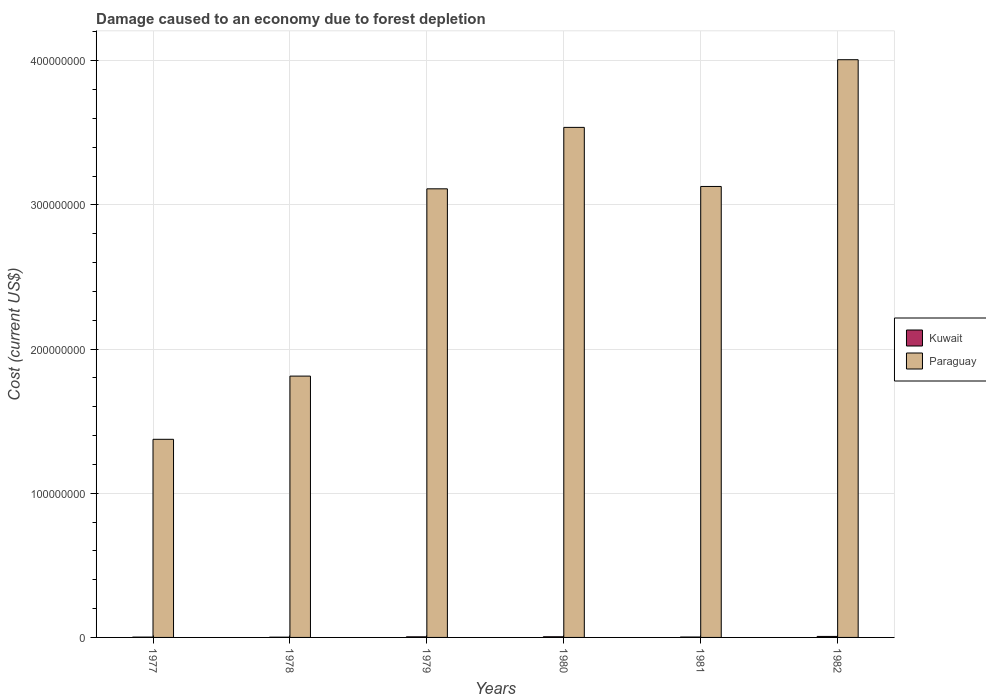Are the number of bars per tick equal to the number of legend labels?
Provide a short and direct response. Yes. How many bars are there on the 5th tick from the left?
Offer a terse response. 2. How many bars are there on the 4th tick from the right?
Make the answer very short. 2. In how many cases, is the number of bars for a given year not equal to the number of legend labels?
Your answer should be compact. 0. What is the cost of damage caused due to forest depletion in Paraguay in 1981?
Provide a succinct answer. 3.13e+08. Across all years, what is the maximum cost of damage caused due to forest depletion in Paraguay?
Your answer should be very brief. 4.01e+08. Across all years, what is the minimum cost of damage caused due to forest depletion in Paraguay?
Your response must be concise. 1.37e+08. In which year was the cost of damage caused due to forest depletion in Paraguay minimum?
Offer a very short reply. 1977. What is the total cost of damage caused due to forest depletion in Kuwait in the graph?
Offer a very short reply. 2.26e+06. What is the difference between the cost of damage caused due to forest depletion in Paraguay in 1979 and that in 1981?
Ensure brevity in your answer.  -1.63e+06. What is the difference between the cost of damage caused due to forest depletion in Paraguay in 1981 and the cost of damage caused due to forest depletion in Kuwait in 1977?
Ensure brevity in your answer.  3.13e+08. What is the average cost of damage caused due to forest depletion in Kuwait per year?
Keep it short and to the point. 3.76e+05. In the year 1977, what is the difference between the cost of damage caused due to forest depletion in Paraguay and cost of damage caused due to forest depletion in Kuwait?
Make the answer very short. 1.37e+08. In how many years, is the cost of damage caused due to forest depletion in Paraguay greater than 140000000 US$?
Offer a very short reply. 5. What is the ratio of the cost of damage caused due to forest depletion in Kuwait in 1979 to that in 1980?
Your answer should be compact. 0.9. Is the difference between the cost of damage caused due to forest depletion in Paraguay in 1977 and 1982 greater than the difference between the cost of damage caused due to forest depletion in Kuwait in 1977 and 1982?
Your answer should be very brief. No. What is the difference between the highest and the second highest cost of damage caused due to forest depletion in Kuwait?
Provide a succinct answer. 2.28e+05. What is the difference between the highest and the lowest cost of damage caused due to forest depletion in Paraguay?
Your answer should be very brief. 2.63e+08. What does the 2nd bar from the left in 1980 represents?
Your answer should be compact. Paraguay. What does the 2nd bar from the right in 1980 represents?
Provide a short and direct response. Kuwait. How many bars are there?
Make the answer very short. 12. What is the difference between two consecutive major ticks on the Y-axis?
Your answer should be compact. 1.00e+08. Are the values on the major ticks of Y-axis written in scientific E-notation?
Offer a terse response. No. Does the graph contain grids?
Your answer should be very brief. Yes. How are the legend labels stacked?
Offer a very short reply. Vertical. What is the title of the graph?
Give a very brief answer. Damage caused to an economy due to forest depletion. What is the label or title of the X-axis?
Your answer should be compact. Years. What is the label or title of the Y-axis?
Give a very brief answer. Cost (current US$). What is the Cost (current US$) of Kuwait in 1977?
Your answer should be compact. 2.24e+05. What is the Cost (current US$) of Paraguay in 1977?
Ensure brevity in your answer.  1.37e+08. What is the Cost (current US$) of Kuwait in 1978?
Provide a short and direct response. 1.75e+05. What is the Cost (current US$) of Paraguay in 1978?
Keep it short and to the point. 1.81e+08. What is the Cost (current US$) of Kuwait in 1979?
Your answer should be very brief. 4.19e+05. What is the Cost (current US$) of Paraguay in 1979?
Your response must be concise. 3.11e+08. What is the Cost (current US$) of Kuwait in 1980?
Your response must be concise. 4.67e+05. What is the Cost (current US$) of Paraguay in 1980?
Make the answer very short. 3.54e+08. What is the Cost (current US$) in Kuwait in 1981?
Offer a terse response. 2.76e+05. What is the Cost (current US$) of Paraguay in 1981?
Provide a succinct answer. 3.13e+08. What is the Cost (current US$) in Kuwait in 1982?
Provide a succinct answer. 6.96e+05. What is the Cost (current US$) of Paraguay in 1982?
Offer a terse response. 4.01e+08. Across all years, what is the maximum Cost (current US$) in Kuwait?
Provide a short and direct response. 6.96e+05. Across all years, what is the maximum Cost (current US$) in Paraguay?
Provide a succinct answer. 4.01e+08. Across all years, what is the minimum Cost (current US$) of Kuwait?
Offer a terse response. 1.75e+05. Across all years, what is the minimum Cost (current US$) in Paraguay?
Ensure brevity in your answer.  1.37e+08. What is the total Cost (current US$) in Kuwait in the graph?
Make the answer very short. 2.26e+06. What is the total Cost (current US$) of Paraguay in the graph?
Give a very brief answer. 1.70e+09. What is the difference between the Cost (current US$) of Kuwait in 1977 and that in 1978?
Ensure brevity in your answer.  4.87e+04. What is the difference between the Cost (current US$) of Paraguay in 1977 and that in 1978?
Your answer should be compact. -4.38e+07. What is the difference between the Cost (current US$) of Kuwait in 1977 and that in 1979?
Give a very brief answer. -1.95e+05. What is the difference between the Cost (current US$) of Paraguay in 1977 and that in 1979?
Offer a terse response. -1.74e+08. What is the difference between the Cost (current US$) of Kuwait in 1977 and that in 1980?
Your answer should be very brief. -2.43e+05. What is the difference between the Cost (current US$) in Paraguay in 1977 and that in 1980?
Offer a terse response. -2.16e+08. What is the difference between the Cost (current US$) of Kuwait in 1977 and that in 1981?
Make the answer very short. -5.13e+04. What is the difference between the Cost (current US$) in Paraguay in 1977 and that in 1981?
Your response must be concise. -1.75e+08. What is the difference between the Cost (current US$) of Kuwait in 1977 and that in 1982?
Your answer should be compact. -4.71e+05. What is the difference between the Cost (current US$) in Paraguay in 1977 and that in 1982?
Offer a very short reply. -2.63e+08. What is the difference between the Cost (current US$) in Kuwait in 1978 and that in 1979?
Provide a short and direct response. -2.44e+05. What is the difference between the Cost (current US$) of Paraguay in 1978 and that in 1979?
Keep it short and to the point. -1.30e+08. What is the difference between the Cost (current US$) in Kuwait in 1978 and that in 1980?
Your response must be concise. -2.92e+05. What is the difference between the Cost (current US$) of Paraguay in 1978 and that in 1980?
Ensure brevity in your answer.  -1.72e+08. What is the difference between the Cost (current US$) of Kuwait in 1978 and that in 1981?
Offer a very short reply. -1.00e+05. What is the difference between the Cost (current US$) in Paraguay in 1978 and that in 1981?
Your answer should be very brief. -1.32e+08. What is the difference between the Cost (current US$) of Kuwait in 1978 and that in 1982?
Offer a very short reply. -5.20e+05. What is the difference between the Cost (current US$) of Paraguay in 1978 and that in 1982?
Give a very brief answer. -2.19e+08. What is the difference between the Cost (current US$) in Kuwait in 1979 and that in 1980?
Provide a succinct answer. -4.83e+04. What is the difference between the Cost (current US$) in Paraguay in 1979 and that in 1980?
Offer a terse response. -4.26e+07. What is the difference between the Cost (current US$) of Kuwait in 1979 and that in 1981?
Give a very brief answer. 1.44e+05. What is the difference between the Cost (current US$) of Paraguay in 1979 and that in 1981?
Make the answer very short. -1.63e+06. What is the difference between the Cost (current US$) in Kuwait in 1979 and that in 1982?
Your answer should be compact. -2.76e+05. What is the difference between the Cost (current US$) in Paraguay in 1979 and that in 1982?
Your response must be concise. -8.95e+07. What is the difference between the Cost (current US$) in Kuwait in 1980 and that in 1981?
Offer a very short reply. 1.92e+05. What is the difference between the Cost (current US$) of Paraguay in 1980 and that in 1981?
Your response must be concise. 4.10e+07. What is the difference between the Cost (current US$) in Kuwait in 1980 and that in 1982?
Your response must be concise. -2.28e+05. What is the difference between the Cost (current US$) of Paraguay in 1980 and that in 1982?
Offer a very short reply. -4.69e+07. What is the difference between the Cost (current US$) in Kuwait in 1981 and that in 1982?
Your response must be concise. -4.20e+05. What is the difference between the Cost (current US$) of Paraguay in 1981 and that in 1982?
Keep it short and to the point. -8.79e+07. What is the difference between the Cost (current US$) of Kuwait in 1977 and the Cost (current US$) of Paraguay in 1978?
Your answer should be very brief. -1.81e+08. What is the difference between the Cost (current US$) in Kuwait in 1977 and the Cost (current US$) in Paraguay in 1979?
Keep it short and to the point. -3.11e+08. What is the difference between the Cost (current US$) of Kuwait in 1977 and the Cost (current US$) of Paraguay in 1980?
Your answer should be very brief. -3.54e+08. What is the difference between the Cost (current US$) in Kuwait in 1977 and the Cost (current US$) in Paraguay in 1981?
Keep it short and to the point. -3.13e+08. What is the difference between the Cost (current US$) in Kuwait in 1977 and the Cost (current US$) in Paraguay in 1982?
Ensure brevity in your answer.  -4.00e+08. What is the difference between the Cost (current US$) in Kuwait in 1978 and the Cost (current US$) in Paraguay in 1979?
Provide a succinct answer. -3.11e+08. What is the difference between the Cost (current US$) of Kuwait in 1978 and the Cost (current US$) of Paraguay in 1980?
Provide a succinct answer. -3.54e+08. What is the difference between the Cost (current US$) of Kuwait in 1978 and the Cost (current US$) of Paraguay in 1981?
Your response must be concise. -3.13e+08. What is the difference between the Cost (current US$) in Kuwait in 1978 and the Cost (current US$) in Paraguay in 1982?
Your answer should be very brief. -4.01e+08. What is the difference between the Cost (current US$) in Kuwait in 1979 and the Cost (current US$) in Paraguay in 1980?
Your answer should be compact. -3.53e+08. What is the difference between the Cost (current US$) of Kuwait in 1979 and the Cost (current US$) of Paraguay in 1981?
Your response must be concise. -3.12e+08. What is the difference between the Cost (current US$) in Kuwait in 1979 and the Cost (current US$) in Paraguay in 1982?
Keep it short and to the point. -4.00e+08. What is the difference between the Cost (current US$) of Kuwait in 1980 and the Cost (current US$) of Paraguay in 1981?
Provide a succinct answer. -3.12e+08. What is the difference between the Cost (current US$) in Kuwait in 1980 and the Cost (current US$) in Paraguay in 1982?
Your answer should be compact. -4.00e+08. What is the difference between the Cost (current US$) of Kuwait in 1981 and the Cost (current US$) of Paraguay in 1982?
Provide a succinct answer. -4.00e+08. What is the average Cost (current US$) of Kuwait per year?
Your answer should be very brief. 3.76e+05. What is the average Cost (current US$) of Paraguay per year?
Your response must be concise. 2.83e+08. In the year 1977, what is the difference between the Cost (current US$) in Kuwait and Cost (current US$) in Paraguay?
Ensure brevity in your answer.  -1.37e+08. In the year 1978, what is the difference between the Cost (current US$) of Kuwait and Cost (current US$) of Paraguay?
Offer a terse response. -1.81e+08. In the year 1979, what is the difference between the Cost (current US$) of Kuwait and Cost (current US$) of Paraguay?
Your answer should be very brief. -3.11e+08. In the year 1980, what is the difference between the Cost (current US$) of Kuwait and Cost (current US$) of Paraguay?
Provide a succinct answer. -3.53e+08. In the year 1981, what is the difference between the Cost (current US$) in Kuwait and Cost (current US$) in Paraguay?
Offer a terse response. -3.12e+08. In the year 1982, what is the difference between the Cost (current US$) of Kuwait and Cost (current US$) of Paraguay?
Offer a terse response. -4.00e+08. What is the ratio of the Cost (current US$) of Kuwait in 1977 to that in 1978?
Give a very brief answer. 1.28. What is the ratio of the Cost (current US$) in Paraguay in 1977 to that in 1978?
Provide a succinct answer. 0.76. What is the ratio of the Cost (current US$) of Kuwait in 1977 to that in 1979?
Your response must be concise. 0.53. What is the ratio of the Cost (current US$) in Paraguay in 1977 to that in 1979?
Offer a very short reply. 0.44. What is the ratio of the Cost (current US$) in Kuwait in 1977 to that in 1980?
Your answer should be compact. 0.48. What is the ratio of the Cost (current US$) of Paraguay in 1977 to that in 1980?
Provide a short and direct response. 0.39. What is the ratio of the Cost (current US$) of Kuwait in 1977 to that in 1981?
Ensure brevity in your answer.  0.81. What is the ratio of the Cost (current US$) in Paraguay in 1977 to that in 1981?
Give a very brief answer. 0.44. What is the ratio of the Cost (current US$) in Kuwait in 1977 to that in 1982?
Your answer should be very brief. 0.32. What is the ratio of the Cost (current US$) in Paraguay in 1977 to that in 1982?
Your answer should be compact. 0.34. What is the ratio of the Cost (current US$) in Kuwait in 1978 to that in 1979?
Make the answer very short. 0.42. What is the ratio of the Cost (current US$) in Paraguay in 1978 to that in 1979?
Your answer should be very brief. 0.58. What is the ratio of the Cost (current US$) in Kuwait in 1978 to that in 1980?
Ensure brevity in your answer.  0.38. What is the ratio of the Cost (current US$) of Paraguay in 1978 to that in 1980?
Offer a very short reply. 0.51. What is the ratio of the Cost (current US$) in Kuwait in 1978 to that in 1981?
Your answer should be compact. 0.64. What is the ratio of the Cost (current US$) of Paraguay in 1978 to that in 1981?
Your answer should be very brief. 0.58. What is the ratio of the Cost (current US$) of Kuwait in 1978 to that in 1982?
Your response must be concise. 0.25. What is the ratio of the Cost (current US$) in Paraguay in 1978 to that in 1982?
Give a very brief answer. 0.45. What is the ratio of the Cost (current US$) in Kuwait in 1979 to that in 1980?
Keep it short and to the point. 0.9. What is the ratio of the Cost (current US$) in Paraguay in 1979 to that in 1980?
Give a very brief answer. 0.88. What is the ratio of the Cost (current US$) of Kuwait in 1979 to that in 1981?
Offer a terse response. 1.52. What is the ratio of the Cost (current US$) in Kuwait in 1979 to that in 1982?
Offer a very short reply. 0.6. What is the ratio of the Cost (current US$) of Paraguay in 1979 to that in 1982?
Your answer should be very brief. 0.78. What is the ratio of the Cost (current US$) in Kuwait in 1980 to that in 1981?
Offer a terse response. 1.7. What is the ratio of the Cost (current US$) of Paraguay in 1980 to that in 1981?
Provide a succinct answer. 1.13. What is the ratio of the Cost (current US$) in Kuwait in 1980 to that in 1982?
Keep it short and to the point. 0.67. What is the ratio of the Cost (current US$) of Paraguay in 1980 to that in 1982?
Make the answer very short. 0.88. What is the ratio of the Cost (current US$) in Kuwait in 1981 to that in 1982?
Make the answer very short. 0.4. What is the ratio of the Cost (current US$) of Paraguay in 1981 to that in 1982?
Provide a short and direct response. 0.78. What is the difference between the highest and the second highest Cost (current US$) in Kuwait?
Ensure brevity in your answer.  2.28e+05. What is the difference between the highest and the second highest Cost (current US$) in Paraguay?
Offer a very short reply. 4.69e+07. What is the difference between the highest and the lowest Cost (current US$) in Kuwait?
Ensure brevity in your answer.  5.20e+05. What is the difference between the highest and the lowest Cost (current US$) in Paraguay?
Offer a very short reply. 2.63e+08. 